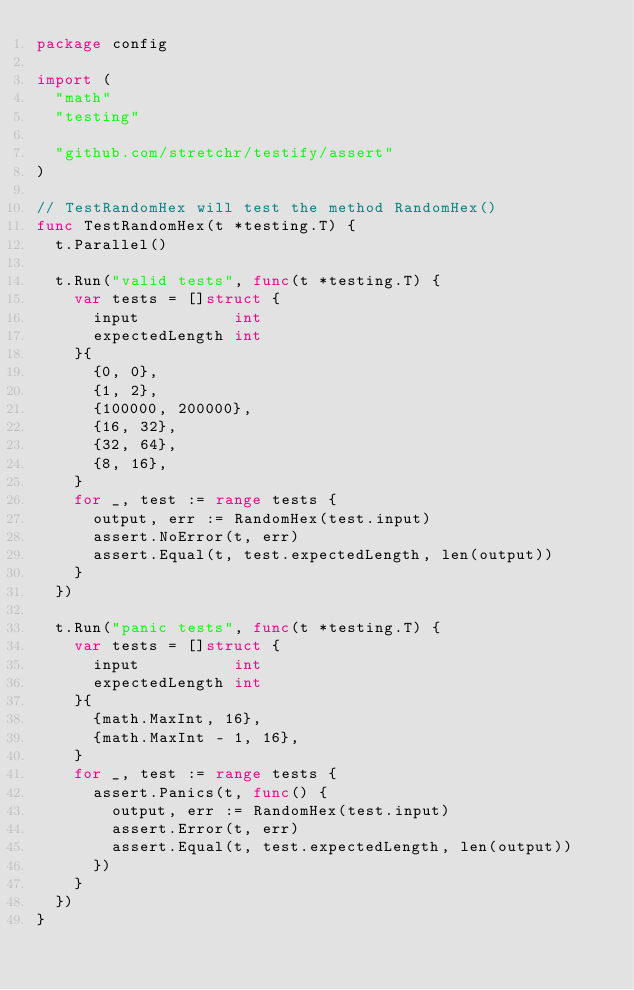<code> <loc_0><loc_0><loc_500><loc_500><_Go_>package config

import (
	"math"
	"testing"

	"github.com/stretchr/testify/assert"
)

// TestRandomHex will test the method RandomHex()
func TestRandomHex(t *testing.T) {
	t.Parallel()

	t.Run("valid tests", func(t *testing.T) {
		var tests = []struct {
			input          int
			expectedLength int
		}{
			{0, 0},
			{1, 2},
			{100000, 200000},
			{16, 32},
			{32, 64},
			{8, 16},
		}
		for _, test := range tests {
			output, err := RandomHex(test.input)
			assert.NoError(t, err)
			assert.Equal(t, test.expectedLength, len(output))
		}
	})

	t.Run("panic tests", func(t *testing.T) {
		var tests = []struct {
			input          int
			expectedLength int
		}{
			{math.MaxInt, 16},
			{math.MaxInt - 1, 16},
		}
		for _, test := range tests {
			assert.Panics(t, func() {
				output, err := RandomHex(test.input)
				assert.Error(t, err)
				assert.Equal(t, test.expectedLength, len(output))
			})
		}
	})
}
</code> 